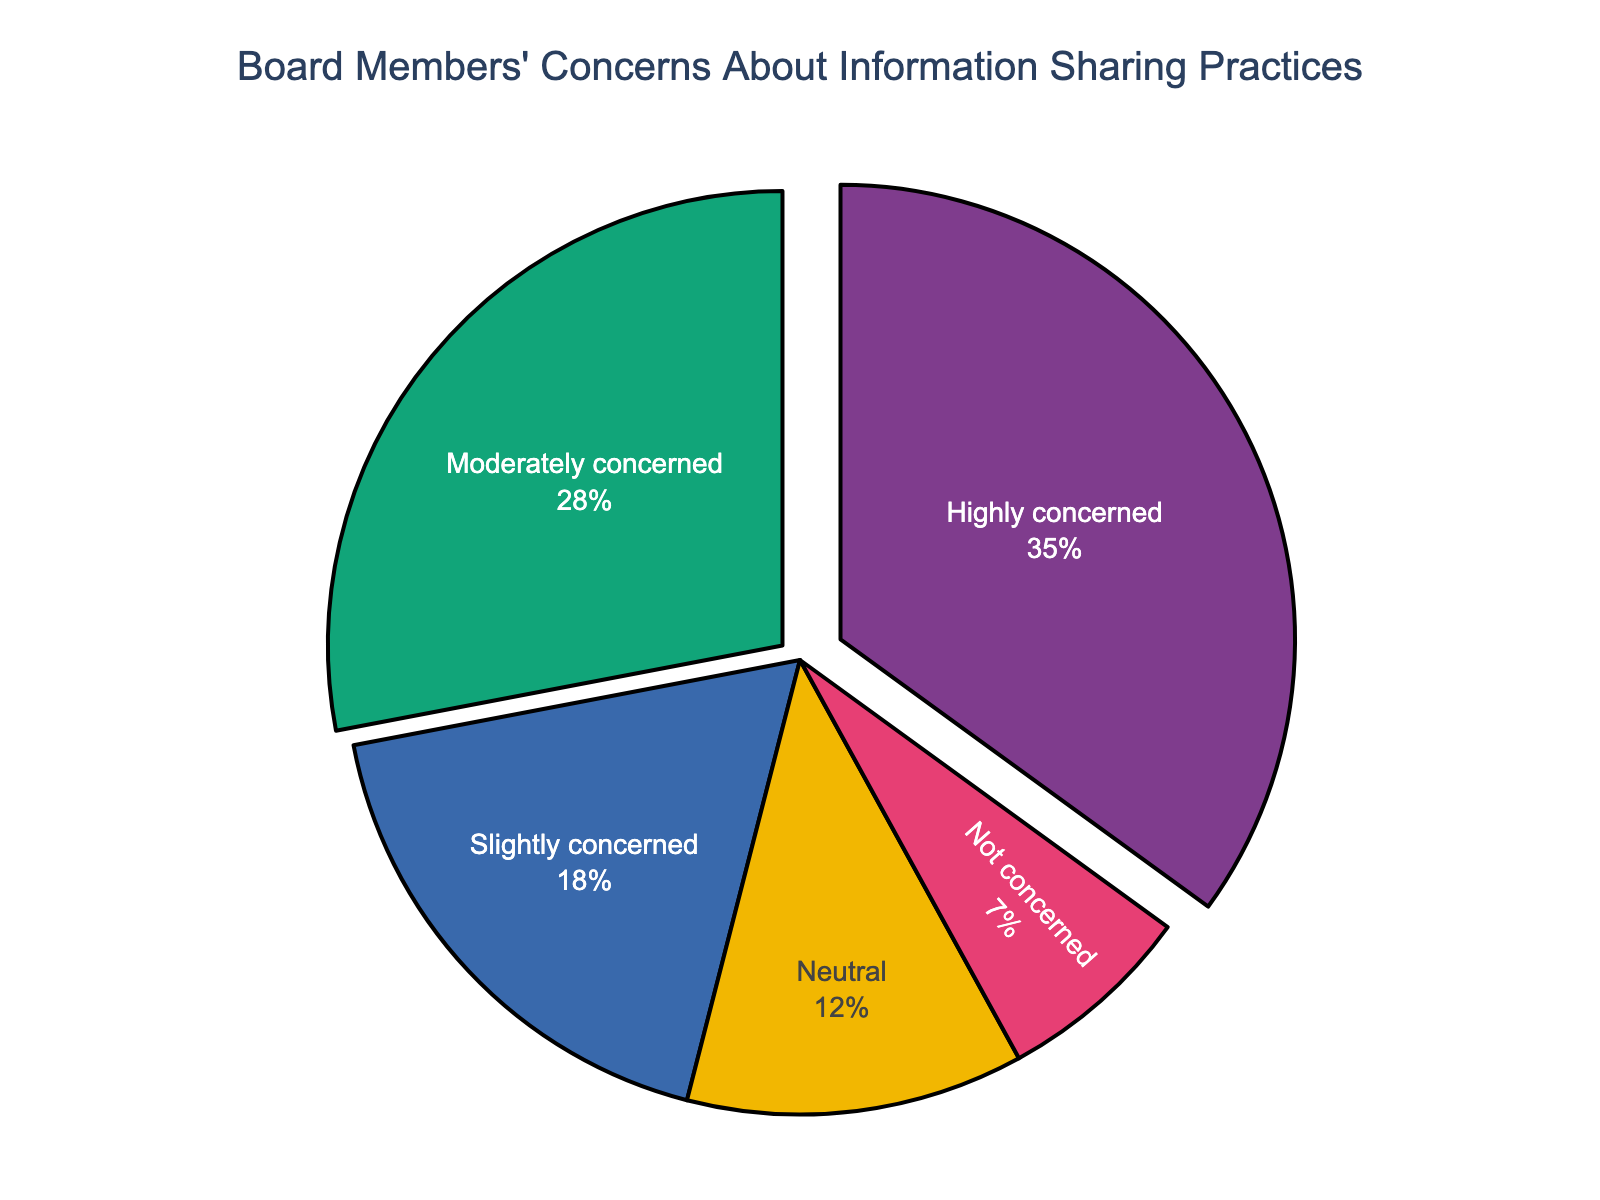How many board members are highly concerned or moderately concerned combined? To find the combined percentage of board members who are highly concerned or moderately concerned, add the percentage of highly concerned (35%) and moderately concerned (28%). This gives 35 + 28 = 63%.
Answer: 63% Which concern level has the highest percentage of board members? By examining the pie chart, the largest section represents the "Highly concerned" category, which accounts for 35% of the board members.
Answer: Highly concerned What is the percentage difference between those who are slightly concerned and those who are not concerned? First, note the percentage of board members who are slightly concerned (18%) and those who are not concerned (7%). The difference is calculated as 18 - 7 = 11%.
Answer: 11% Which is greater, the percentage of board members who are neutral or those who are not concerned, and by how much? The percentage of board members who are neutral is 12%, and those who are not concerned is 7%. The neutral percentage is higher, and the difference is 12 - 7 = 5%.
Answer: Neutral by 5% What is the cumulative percentage of board members who are either neutral or slightly concerned? Add the percentages of board members who are neutral (12%) and those who are slightly concerned (18%). The sum is 12 + 18 = 30%.
Answer: 30% Which slice is pulled out the most, and what level of concern does it represent? The most pulled out slice can be visually identified from the pie chart. It represents the "Highly concerned" category.
Answer: Highly concerned If you combine the percentages of board members who are neutral, slightly concerned, and not concerned, do they exceed the percentage of those who are highly concerned? To check, sum the percentages of neutral (12%), slightly concerned (18%), and not concerned (7%). The total is 12 + 18 + 7 = 37%. Compare this with the highly concerned percentage (35%), and 37% is indeed greater than 35%.
Answer: Yes How does the percentage of moderately concerned board members compare to those who are neutral? The percentage of moderately concerned board members is 28%, while those who are neutral is 12%. Thus, the percentage of moderately concerned is greater, with a difference of 28 - 12 = 16%.
Answer: Moderately concerned by 16% What is the combined percentage of board members who are either highly concerned or slightly concerned? Combine the percentages of highly concerned (35%) and slightly concerned (18%). This is 35 + 18 = 53%.
Answer: 53% 